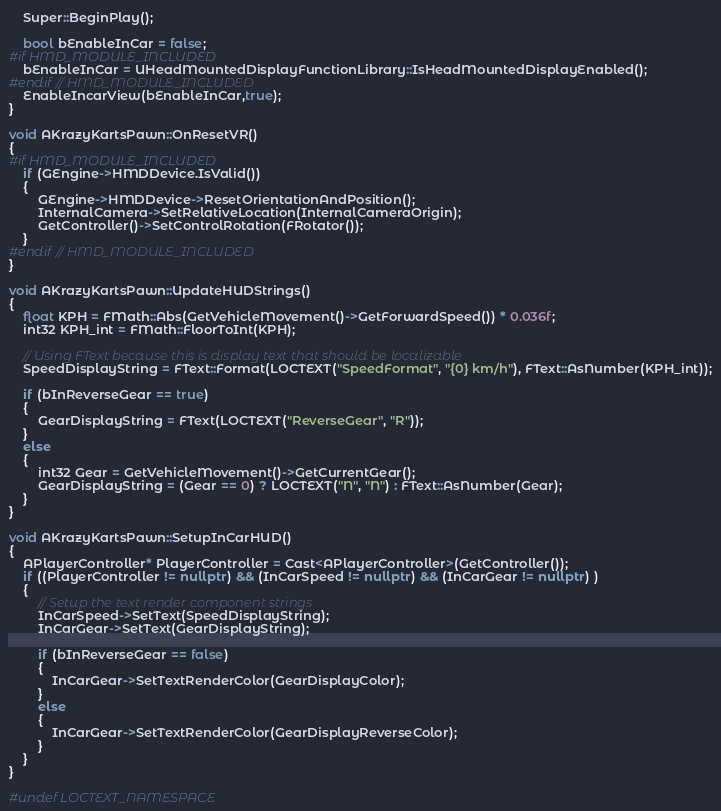<code> <loc_0><loc_0><loc_500><loc_500><_C++_>	Super::BeginPlay();

	bool bEnableInCar = false;
#if HMD_MODULE_INCLUDED
	bEnableInCar = UHeadMountedDisplayFunctionLibrary::IsHeadMountedDisplayEnabled();
#endif // HMD_MODULE_INCLUDED
	EnableIncarView(bEnableInCar,true);
}

void AKrazyKartsPawn::OnResetVR()
{
#if HMD_MODULE_INCLUDED
	if (GEngine->HMDDevice.IsValid())
	{
		GEngine->HMDDevice->ResetOrientationAndPosition();
		InternalCamera->SetRelativeLocation(InternalCameraOrigin);
		GetController()->SetControlRotation(FRotator());
	}
#endif // HMD_MODULE_INCLUDED
}

void AKrazyKartsPawn::UpdateHUDStrings()
{
	float KPH = FMath::Abs(GetVehicleMovement()->GetForwardSpeed()) * 0.036f;
	int32 KPH_int = FMath::FloorToInt(KPH);

	// Using FText because this is display text that should be localizable
	SpeedDisplayString = FText::Format(LOCTEXT("SpeedFormat", "{0} km/h"), FText::AsNumber(KPH_int));
	
	if (bInReverseGear == true)
	{
		GearDisplayString = FText(LOCTEXT("ReverseGear", "R"));
	}
	else
	{
		int32 Gear = GetVehicleMovement()->GetCurrentGear();
		GearDisplayString = (Gear == 0) ? LOCTEXT("N", "N") : FText::AsNumber(Gear);
	}	
}

void AKrazyKartsPawn::SetupInCarHUD()
{
	APlayerController* PlayerController = Cast<APlayerController>(GetController());
	if ((PlayerController != nullptr) && (InCarSpeed != nullptr) && (InCarGear != nullptr) )
	{
		// Setup the text render component strings
		InCarSpeed->SetText(SpeedDisplayString);
		InCarGear->SetText(GearDisplayString);
		
		if (bInReverseGear == false)
		{
			InCarGear->SetTextRenderColor(GearDisplayColor);
		}
		else
		{
			InCarGear->SetTextRenderColor(GearDisplayReverseColor);
		}
	}
}

#undef LOCTEXT_NAMESPACE
</code> 